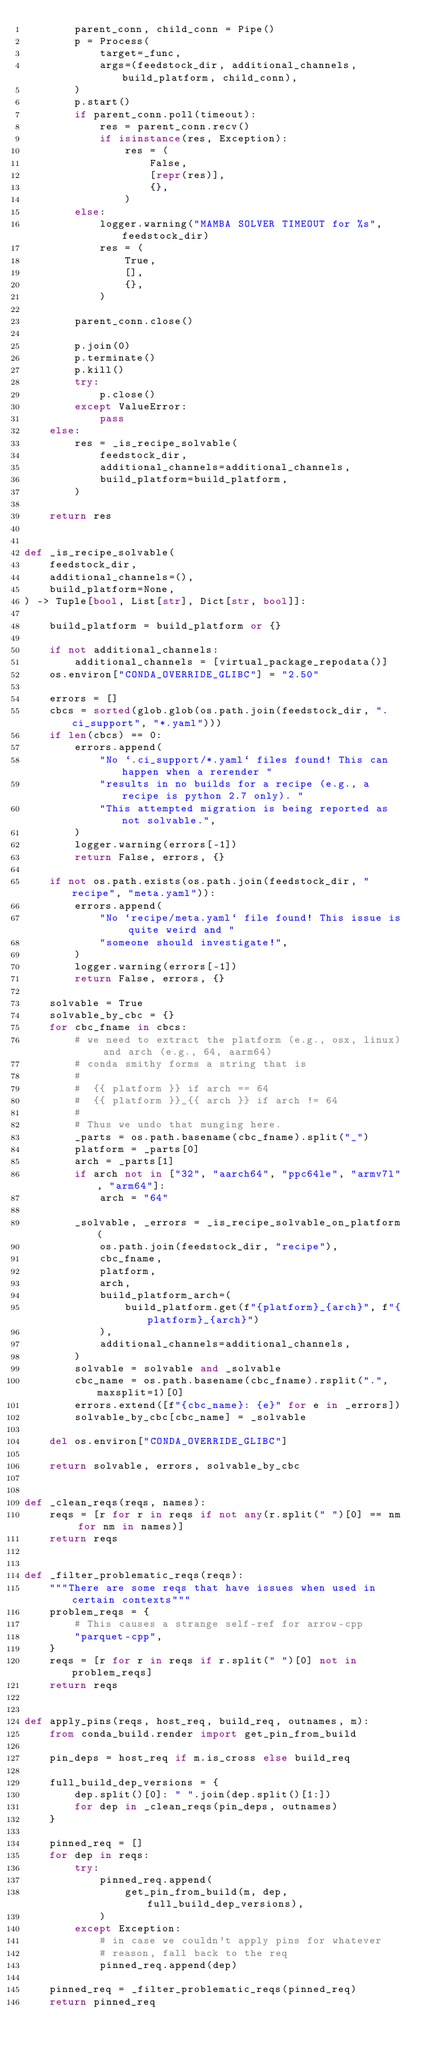Convert code to text. <code><loc_0><loc_0><loc_500><loc_500><_Python_>        parent_conn, child_conn = Pipe()
        p = Process(
            target=_func,
            args=(feedstock_dir, additional_channels, build_platform, child_conn),
        )
        p.start()
        if parent_conn.poll(timeout):
            res = parent_conn.recv()
            if isinstance(res, Exception):
                res = (
                    False,
                    [repr(res)],
                    {},
                )
        else:
            logger.warning("MAMBA SOLVER TIMEOUT for %s", feedstock_dir)
            res = (
                True,
                [],
                {},
            )

        parent_conn.close()

        p.join(0)
        p.terminate()
        p.kill()
        try:
            p.close()
        except ValueError:
            pass
    else:
        res = _is_recipe_solvable(
            feedstock_dir,
            additional_channels=additional_channels,
            build_platform=build_platform,
        )

    return res


def _is_recipe_solvable(
    feedstock_dir,
    additional_channels=(),
    build_platform=None,
) -> Tuple[bool, List[str], Dict[str, bool]]:

    build_platform = build_platform or {}

    if not additional_channels:
        additional_channels = [virtual_package_repodata()]
    os.environ["CONDA_OVERRIDE_GLIBC"] = "2.50"

    errors = []
    cbcs = sorted(glob.glob(os.path.join(feedstock_dir, ".ci_support", "*.yaml")))
    if len(cbcs) == 0:
        errors.append(
            "No `.ci_support/*.yaml` files found! This can happen when a rerender "
            "results in no builds for a recipe (e.g., a recipe is python 2.7 only). "
            "This attempted migration is being reported as not solvable.",
        )
        logger.warning(errors[-1])
        return False, errors, {}

    if not os.path.exists(os.path.join(feedstock_dir, "recipe", "meta.yaml")):
        errors.append(
            "No `recipe/meta.yaml` file found! This issue is quite weird and "
            "someone should investigate!",
        )
        logger.warning(errors[-1])
        return False, errors, {}

    solvable = True
    solvable_by_cbc = {}
    for cbc_fname in cbcs:
        # we need to extract the platform (e.g., osx, linux) and arch (e.g., 64, aarm64)
        # conda smithy forms a string that is
        #
        #  {{ platform }} if arch == 64
        #  {{ platform }}_{{ arch }} if arch != 64
        #
        # Thus we undo that munging here.
        _parts = os.path.basename(cbc_fname).split("_")
        platform = _parts[0]
        arch = _parts[1]
        if arch not in ["32", "aarch64", "ppc64le", "armv7l", "arm64"]:
            arch = "64"

        _solvable, _errors = _is_recipe_solvable_on_platform(
            os.path.join(feedstock_dir, "recipe"),
            cbc_fname,
            platform,
            arch,
            build_platform_arch=(
                build_platform.get(f"{platform}_{arch}", f"{platform}_{arch}")
            ),
            additional_channels=additional_channels,
        )
        solvable = solvable and _solvable
        cbc_name = os.path.basename(cbc_fname).rsplit(".", maxsplit=1)[0]
        errors.extend([f"{cbc_name}: {e}" for e in _errors])
        solvable_by_cbc[cbc_name] = _solvable

    del os.environ["CONDA_OVERRIDE_GLIBC"]

    return solvable, errors, solvable_by_cbc


def _clean_reqs(reqs, names):
    reqs = [r for r in reqs if not any(r.split(" ")[0] == nm for nm in names)]
    return reqs


def _filter_problematic_reqs(reqs):
    """There are some reqs that have issues when used in certain contexts"""
    problem_reqs = {
        # This causes a strange self-ref for arrow-cpp
        "parquet-cpp",
    }
    reqs = [r for r in reqs if r.split(" ")[0] not in problem_reqs]
    return reqs


def apply_pins(reqs, host_req, build_req, outnames, m):
    from conda_build.render import get_pin_from_build

    pin_deps = host_req if m.is_cross else build_req

    full_build_dep_versions = {
        dep.split()[0]: " ".join(dep.split()[1:])
        for dep in _clean_reqs(pin_deps, outnames)
    }

    pinned_req = []
    for dep in reqs:
        try:
            pinned_req.append(
                get_pin_from_build(m, dep, full_build_dep_versions),
            )
        except Exception:
            # in case we couldn't apply pins for whatever
            # reason, fall back to the req
            pinned_req.append(dep)

    pinned_req = _filter_problematic_reqs(pinned_req)
    return pinned_req

</code> 